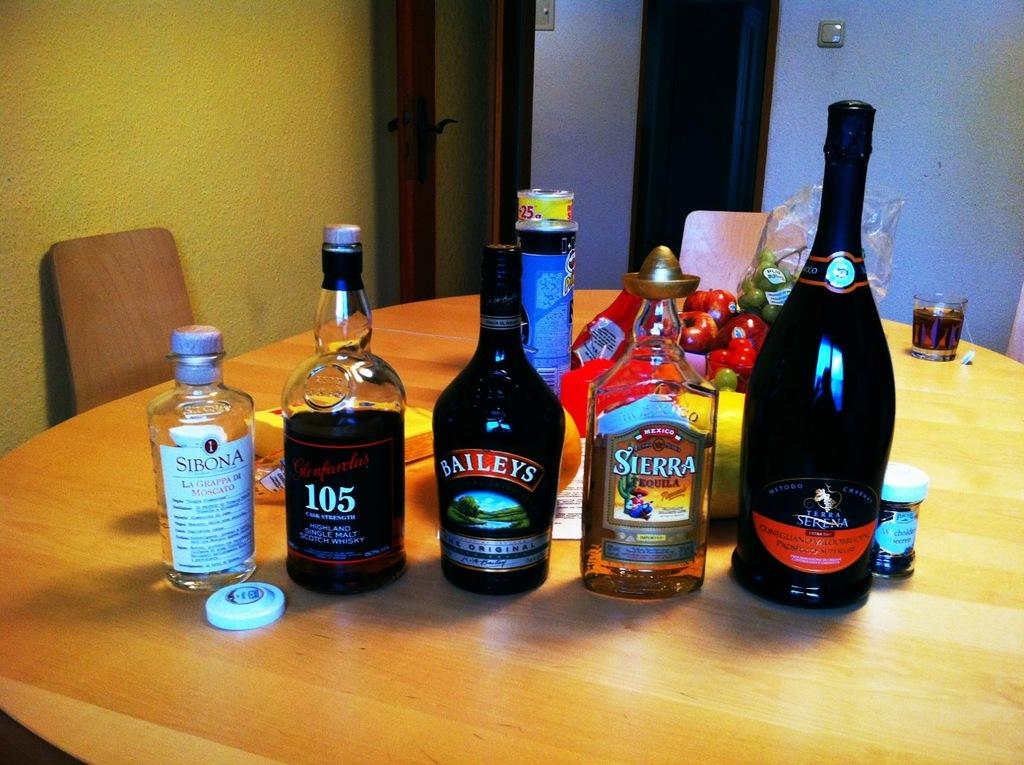<image>
Provide a brief description of the given image. Several bottles from sitting on a table including Bailey's, Sierra, 105 and Sibona. 